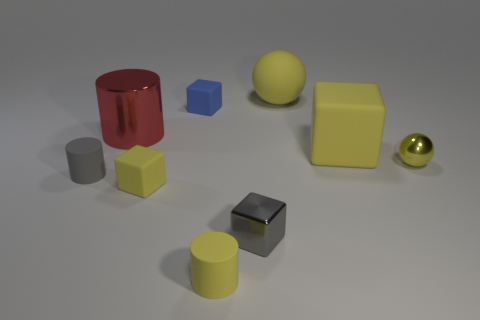Subtract 1 blocks. How many blocks are left? 3 Subtract all brown blocks. Subtract all red cylinders. How many blocks are left? 4 Add 1 tiny yellow metallic spheres. How many objects exist? 10 Subtract all balls. How many objects are left? 7 Add 4 red metallic cylinders. How many red metallic cylinders exist? 5 Subtract 0 blue cylinders. How many objects are left? 9 Subtract all yellow blocks. Subtract all yellow metallic balls. How many objects are left? 6 Add 5 small blue rubber cubes. How many small blue rubber cubes are left? 6 